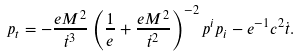Convert formula to latex. <formula><loc_0><loc_0><loc_500><loc_500>p _ { t } = - \frac { e M ^ { 2 } } { \dot { t } ^ { 3 } } \left ( \frac { 1 } { e } + \frac { e M ^ { 2 } } { \dot { t } ^ { 2 } } \right ) ^ { - 2 } p ^ { i } p _ { i } - e ^ { - 1 } c ^ { 2 } \dot { t } .</formula> 